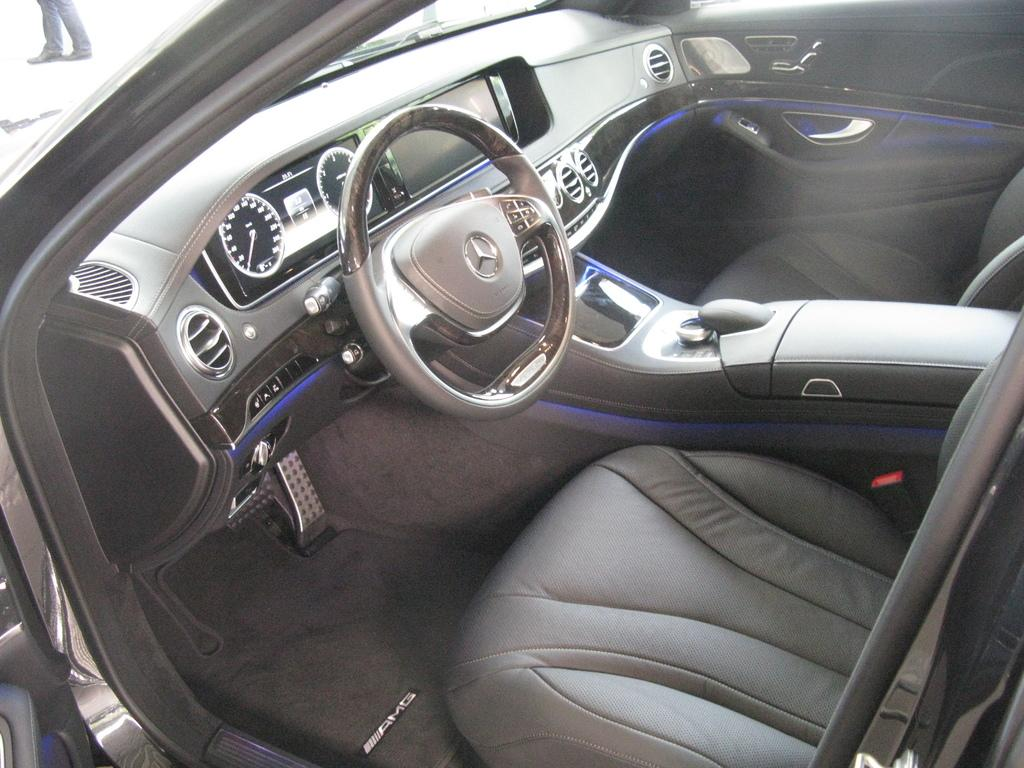What is the setting of the image? The image shows the interior of a car. What can be found inside the car? There are seats and a steering wheel visible in the car. What color is the interior of the car? The car interior is in ash color. Can you see any part of a person in the image? Yes, a person's legs are visible in the back of the car. What type of sky can be seen through the car's windows in the image? The image does not show the car's windows or any sky; it only shows the interior of the car. Can you hear any sounds coming from the car in the image? The image is a still picture and does not include any sounds or audio. 